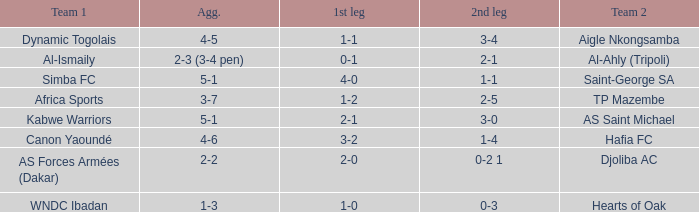What was the 2nd leg result in the match that scored a 2-0 in the 1st leg? 0-2 1. 